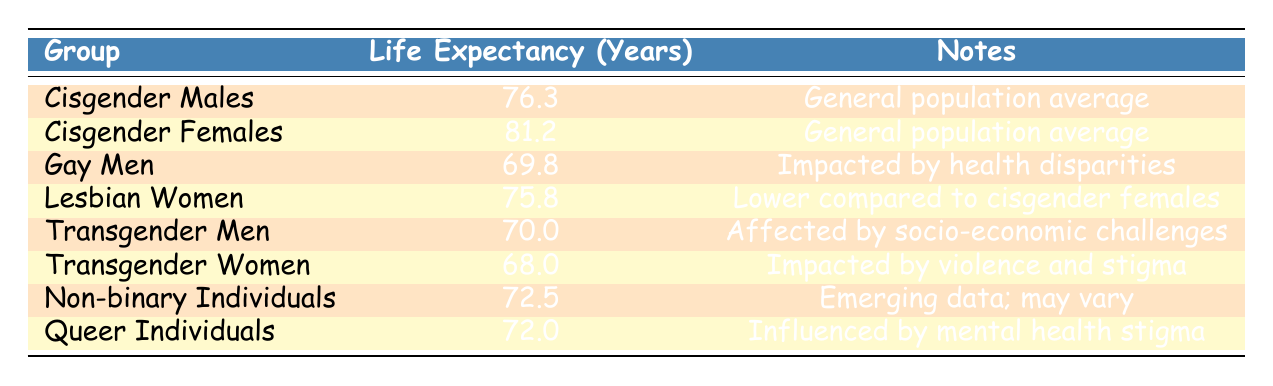What is the life expectancy of Cisgender Females in the United States? The table shows the life expectancy of Cisgender Females as 81.2 years under the country United States for the year 2020.
Answer: 81.2 How does the life expectancy of Gay Men compare to Cisgender Males? According to the table, Gay Men's life expectancy is 69.8 years, while Cisgender Males have a life expectancy of 76.3 years. The difference is 76.3 - 69.8 = 6.5 years.
Answer: Gay Men live 6.5 years less Which group has the lowest life expectancy? The table lists Transgender Women as having the lowest life expectancy at 68.0 years in the United States for the year 2020.
Answer: Transgender Women Is it true that Non-binary Individuals have a longer life expectancy than Lesbian Women? The life expectancy for Non-binary Individuals is 72.5 years, whereas for Lesbian Women it is 75.8 years. Since 72.5 is less than 75.8, the statement is false.
Answer: No What is the average life expectancy of Cisgender Males and Gay Men combined? To calculate the average, we add the life expectancy of Cisgender Males (76.3) and Gay Men (69.8), which equals 146.1 years. Then, we divide by the total number of groups (2): 146.1 / 2 = 73.05 years.
Answer: 73.05 Which group has a life expectancy that is closer to the average of all groups in the table? First, calculate the average life expectancy of all groups. The total is 76.3 + 81.2 + 69.8 + 75.8 + 70 + 68 + 72.5 + 72 = 585.6 years for 8 groups, giving an average of 585.6 / 8 = 73.2 years. The closest life expectancy is that of Non-binary Individuals at 72.5 years.
Answer: Non-binary Individuals Do Lesbian Women have a life expectancy greater than both Transgender Men and Transgender Women? Lesbian Women's life expectancy is 75.8 years. Transgender Men have a life expectancy of 70.0 years, and Transgender Women have 68.0 years. Since 75.8 is greater than both, the statement is true.
Answer: Yes What is the difference between the life expectancies of Queer Individuals and Transgender Women? The life expectancy of Queer Individuals is 72.0 years, and for Transgender Women, it is 68.0 years. The difference is 72.0 - 68.0 = 4.0 years.
Answer: 4.0 